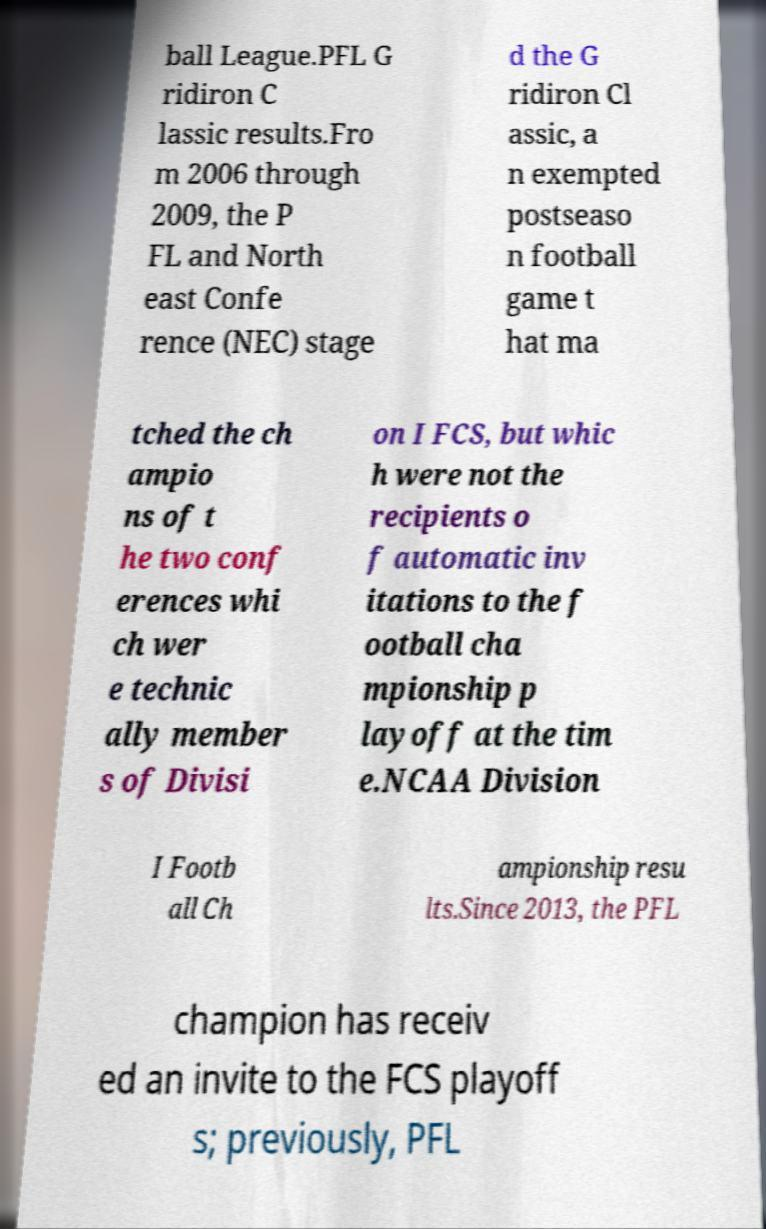I need the written content from this picture converted into text. Can you do that? ball League.PFL G ridiron C lassic results.Fro m 2006 through 2009, the P FL and North east Confe rence (NEC) stage d the G ridiron Cl assic, a n exempted postseaso n football game t hat ma tched the ch ampio ns of t he two conf erences whi ch wer e technic ally member s of Divisi on I FCS, but whic h were not the recipients o f automatic inv itations to the f ootball cha mpionship p layoff at the tim e.NCAA Division I Footb all Ch ampionship resu lts.Since 2013, the PFL champion has receiv ed an invite to the FCS playoff s; previously, PFL 